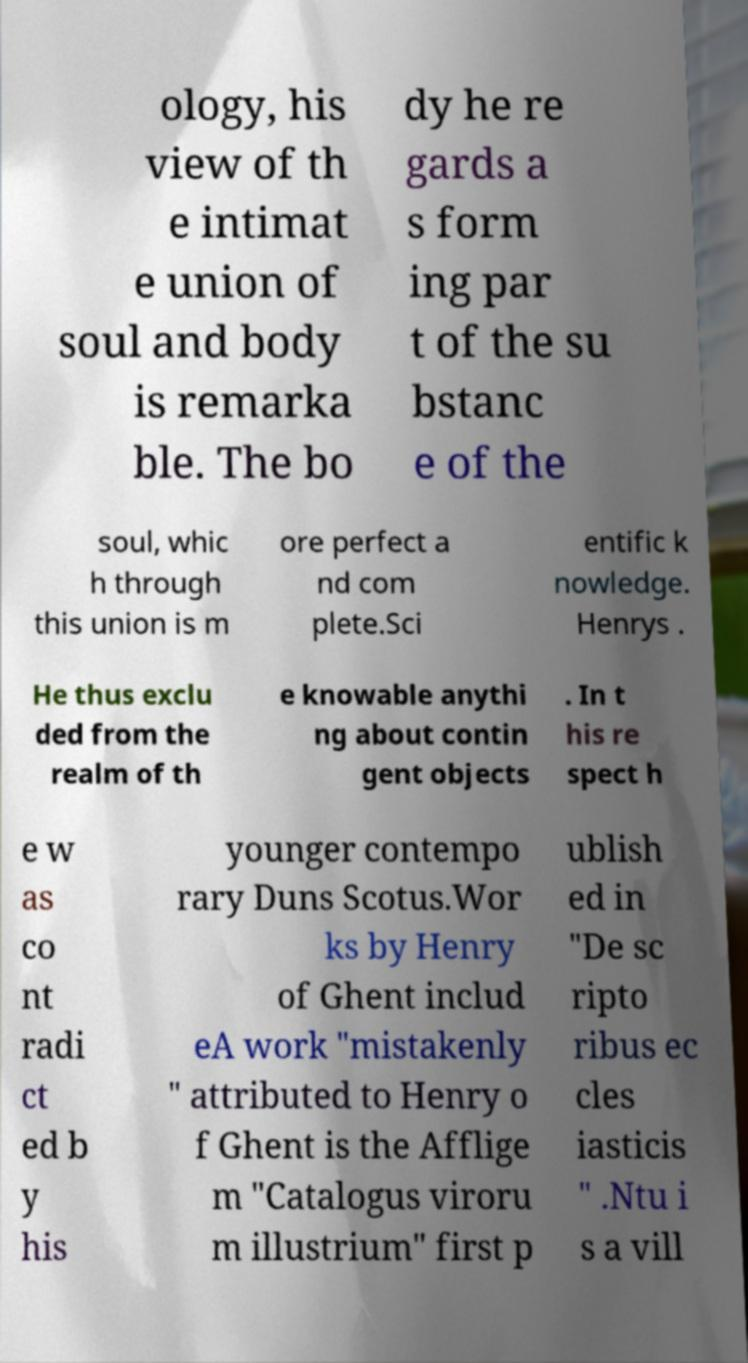Could you extract and type out the text from this image? ology, his view of th e intimat e union of soul and body is remarka ble. The bo dy he re gards a s form ing par t of the su bstanc e of the soul, whic h through this union is m ore perfect a nd com plete.Sci entific k nowledge. Henrys . He thus exclu ded from the realm of th e knowable anythi ng about contin gent objects . In t his re spect h e w as co nt radi ct ed b y his younger contempo rary Duns Scotus.Wor ks by Henry of Ghent includ eA work "mistakenly " attributed to Henry o f Ghent is the Afflige m "Catalogus viroru m illustrium" first p ublish ed in "De sc ripto ribus ec cles iasticis " .Ntu i s a vill 